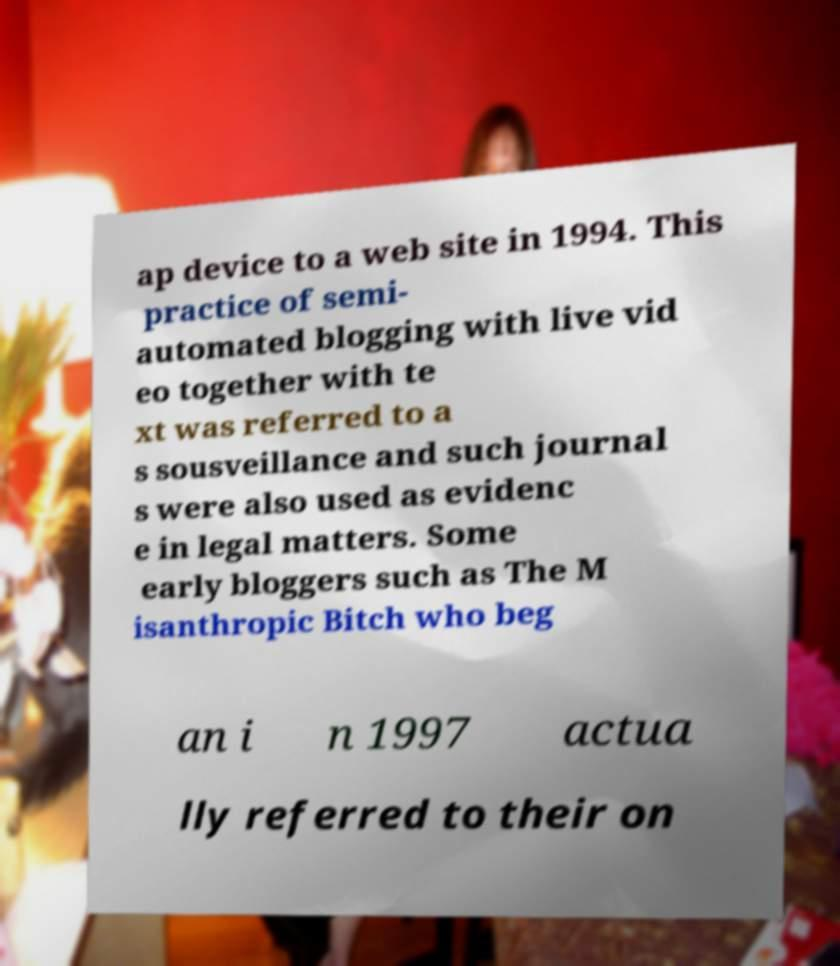There's text embedded in this image that I need extracted. Can you transcribe it verbatim? ap device to a web site in 1994. This practice of semi- automated blogging with live vid eo together with te xt was referred to a s sousveillance and such journal s were also used as evidenc e in legal matters. Some early bloggers such as The M isanthropic Bitch who beg an i n 1997 actua lly referred to their on 